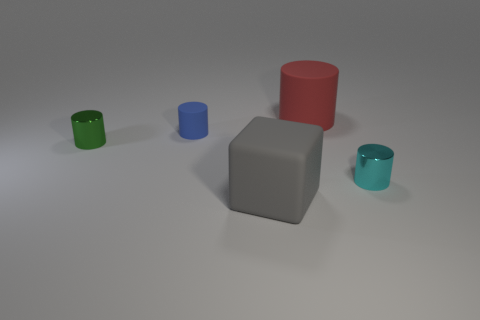Add 4 tiny cylinders. How many objects exist? 9 Subtract all blocks. How many objects are left? 4 Subtract all big gray shiny cylinders. Subtract all large red objects. How many objects are left? 4 Add 1 green cylinders. How many green cylinders are left? 2 Add 2 tiny red shiny cylinders. How many tiny red shiny cylinders exist? 2 Subtract 0 yellow spheres. How many objects are left? 5 